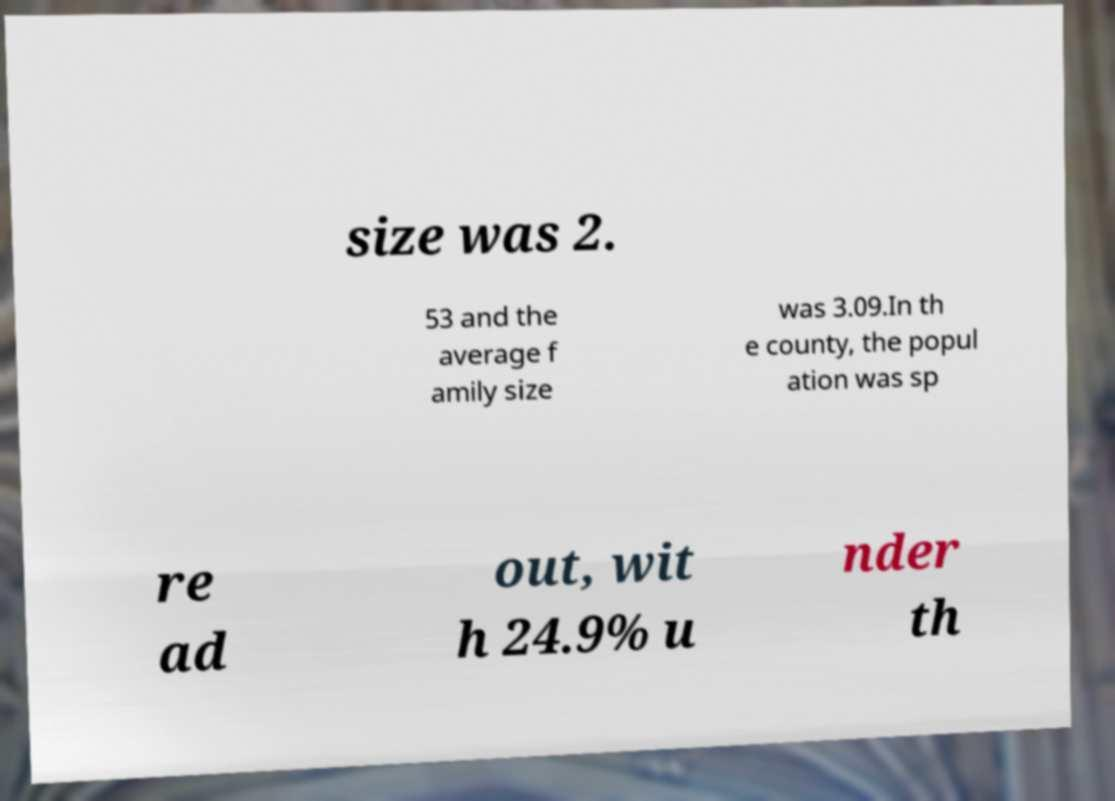There's text embedded in this image that I need extracted. Can you transcribe it verbatim? size was 2. 53 and the average f amily size was 3.09.In th e county, the popul ation was sp re ad out, wit h 24.9% u nder th 